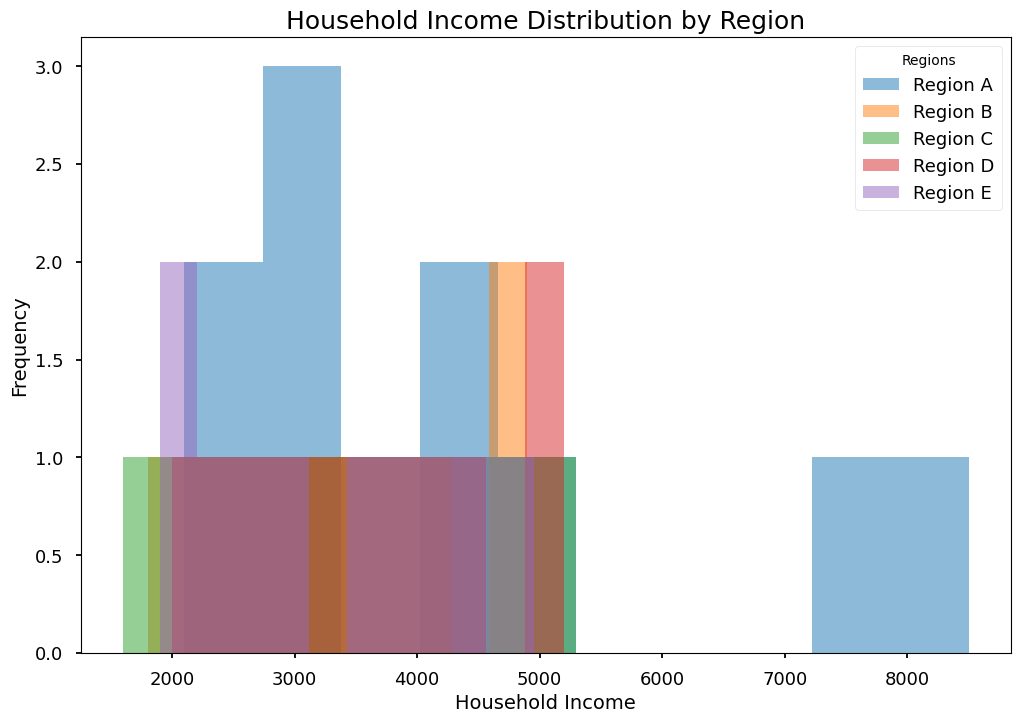Which region has the highest peak in household income distribution? To answer this, look for the region with the tallest bar in the histogram. This indicates the highest frequency of household incomes.
Answer: Region A Which region shows the most spread-out distribution of household income? Identify the region where the bars cover the most extensive range on the x-axis. This means household incomes in this region have the widest variation.
Answer: Region E What is the median household income range for Region C? Find the range on the x-axis that corresponds to the middlemost bar(s) for Region C. This can be observed as the central point in the distribution of household incomes.
Answer: 3600–4300 Compare the median household incomes of Region B and Region D. Which one is higher? Locate the middlemost bar(s) for both regions and compare their x-axis positions to determine which is further to the right.
Answer: Region D How does the average household income of Region A compare with Region B? To determine this, visually estimate the central tendency of the bars for both regions and compare their average positions on the x-axis. The region with the bars more towards the right will have a higher average.
Answer: Region A Which region has the least frequent low-income households (below 2000)? Check the leftmost bars of each region in the histogram to see which region has the fewest or no bars in this range.
Answer: Region A Is there a region where no households fall above 5000 in income? If yes, which one? Identify any region where bars end before or at the 5000 mark on the x-axis.
Answer: Region B Which region shows a clear peak around the household income of 3100? Look for the region with a bar peaking significantly at or near the 3100 mark on the x-axis.
Answer: Region C Which regions show a significant number of household incomes between 4000 and 5000? Observe the histogram for bars within the 4000 to 5000 range for each region, and note which regions have higher frequency bars in this range.
Answer: Regions A, C, D, E Are there more households with income above 4000 in Region A or Region E? Compare the height of the bars above the 4000 mark in both regions. The region with the higher bars has more households with income greater than 4000.
Answer: Region A 